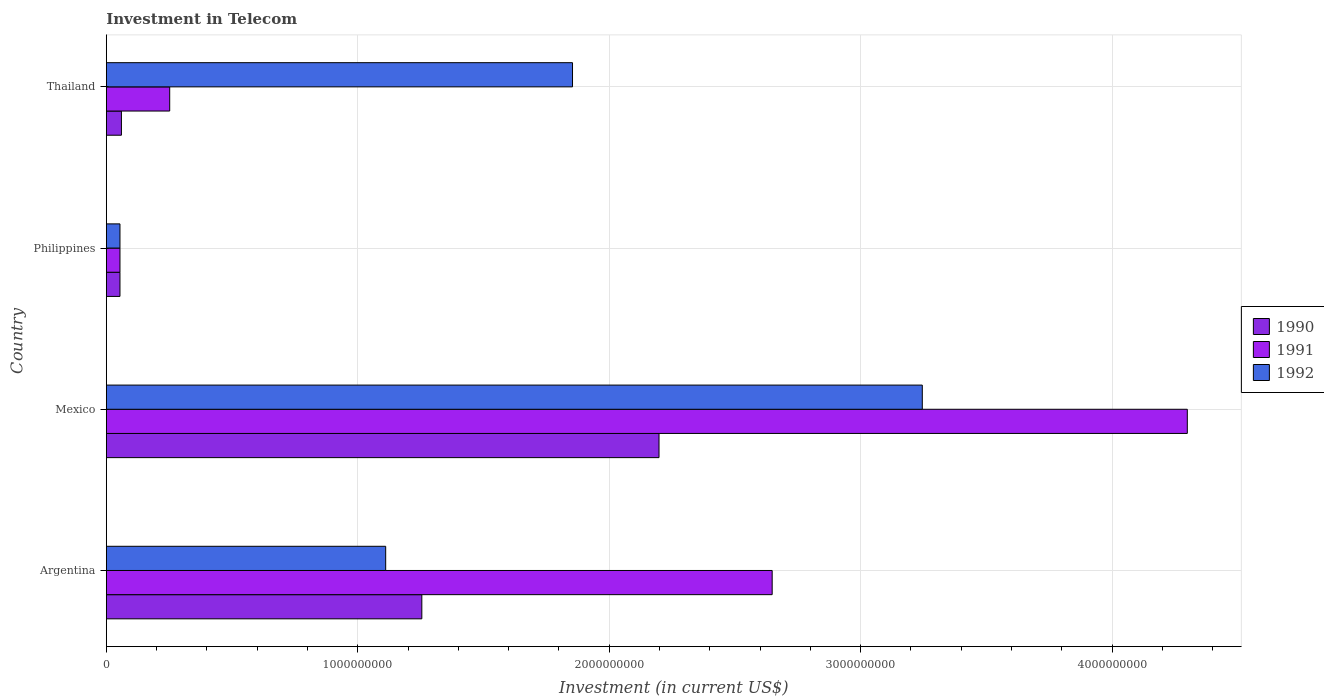How many groups of bars are there?
Offer a very short reply. 4. Are the number of bars per tick equal to the number of legend labels?
Offer a terse response. Yes. Are the number of bars on each tick of the Y-axis equal?
Keep it short and to the point. Yes. How many bars are there on the 2nd tick from the top?
Your answer should be compact. 3. What is the amount invested in telecom in 1992 in Philippines?
Ensure brevity in your answer.  5.42e+07. Across all countries, what is the maximum amount invested in telecom in 1991?
Give a very brief answer. 4.30e+09. Across all countries, what is the minimum amount invested in telecom in 1991?
Your response must be concise. 5.42e+07. What is the total amount invested in telecom in 1990 in the graph?
Offer a terse response. 3.57e+09. What is the difference between the amount invested in telecom in 1990 in Philippines and that in Thailand?
Provide a short and direct response. -5.80e+06. What is the difference between the amount invested in telecom in 1990 in Argentina and the amount invested in telecom in 1991 in Thailand?
Provide a succinct answer. 1.00e+09. What is the average amount invested in telecom in 1992 per country?
Provide a succinct answer. 1.57e+09. What is the difference between the amount invested in telecom in 1990 and amount invested in telecom in 1992 in Mexico?
Provide a succinct answer. -1.05e+09. What is the ratio of the amount invested in telecom in 1990 in Argentina to that in Mexico?
Your answer should be compact. 0.57. What is the difference between the highest and the second highest amount invested in telecom in 1991?
Make the answer very short. 1.65e+09. What is the difference between the highest and the lowest amount invested in telecom in 1992?
Your answer should be very brief. 3.19e+09. In how many countries, is the amount invested in telecom in 1991 greater than the average amount invested in telecom in 1991 taken over all countries?
Your answer should be very brief. 2. What does the 1st bar from the bottom in Thailand represents?
Your answer should be very brief. 1990. Is it the case that in every country, the sum of the amount invested in telecom in 1992 and amount invested in telecom in 1990 is greater than the amount invested in telecom in 1991?
Offer a very short reply. No. How many countries are there in the graph?
Offer a terse response. 4. Are the values on the major ticks of X-axis written in scientific E-notation?
Offer a terse response. No. Does the graph contain any zero values?
Offer a very short reply. No. Where does the legend appear in the graph?
Your answer should be very brief. Center right. How many legend labels are there?
Your response must be concise. 3. What is the title of the graph?
Offer a terse response. Investment in Telecom. Does "1977" appear as one of the legend labels in the graph?
Make the answer very short. No. What is the label or title of the X-axis?
Offer a very short reply. Investment (in current US$). What is the Investment (in current US$) in 1990 in Argentina?
Give a very brief answer. 1.25e+09. What is the Investment (in current US$) in 1991 in Argentina?
Offer a very short reply. 2.65e+09. What is the Investment (in current US$) of 1992 in Argentina?
Your answer should be compact. 1.11e+09. What is the Investment (in current US$) in 1990 in Mexico?
Provide a short and direct response. 2.20e+09. What is the Investment (in current US$) of 1991 in Mexico?
Give a very brief answer. 4.30e+09. What is the Investment (in current US$) of 1992 in Mexico?
Give a very brief answer. 3.24e+09. What is the Investment (in current US$) of 1990 in Philippines?
Your response must be concise. 5.42e+07. What is the Investment (in current US$) in 1991 in Philippines?
Provide a succinct answer. 5.42e+07. What is the Investment (in current US$) in 1992 in Philippines?
Provide a short and direct response. 5.42e+07. What is the Investment (in current US$) in 1990 in Thailand?
Your answer should be compact. 6.00e+07. What is the Investment (in current US$) of 1991 in Thailand?
Your answer should be very brief. 2.52e+08. What is the Investment (in current US$) in 1992 in Thailand?
Make the answer very short. 1.85e+09. Across all countries, what is the maximum Investment (in current US$) of 1990?
Your answer should be very brief. 2.20e+09. Across all countries, what is the maximum Investment (in current US$) of 1991?
Make the answer very short. 4.30e+09. Across all countries, what is the maximum Investment (in current US$) of 1992?
Your answer should be very brief. 3.24e+09. Across all countries, what is the minimum Investment (in current US$) in 1990?
Provide a short and direct response. 5.42e+07. Across all countries, what is the minimum Investment (in current US$) of 1991?
Make the answer very short. 5.42e+07. Across all countries, what is the minimum Investment (in current US$) in 1992?
Your answer should be compact. 5.42e+07. What is the total Investment (in current US$) of 1990 in the graph?
Make the answer very short. 3.57e+09. What is the total Investment (in current US$) of 1991 in the graph?
Make the answer very short. 7.25e+09. What is the total Investment (in current US$) of 1992 in the graph?
Make the answer very short. 6.26e+09. What is the difference between the Investment (in current US$) of 1990 in Argentina and that in Mexico?
Give a very brief answer. -9.43e+08. What is the difference between the Investment (in current US$) of 1991 in Argentina and that in Mexico?
Ensure brevity in your answer.  -1.65e+09. What is the difference between the Investment (in current US$) of 1992 in Argentina and that in Mexico?
Your answer should be very brief. -2.13e+09. What is the difference between the Investment (in current US$) of 1990 in Argentina and that in Philippines?
Your answer should be compact. 1.20e+09. What is the difference between the Investment (in current US$) in 1991 in Argentina and that in Philippines?
Offer a terse response. 2.59e+09. What is the difference between the Investment (in current US$) of 1992 in Argentina and that in Philippines?
Provide a short and direct response. 1.06e+09. What is the difference between the Investment (in current US$) in 1990 in Argentina and that in Thailand?
Your answer should be compact. 1.19e+09. What is the difference between the Investment (in current US$) in 1991 in Argentina and that in Thailand?
Provide a succinct answer. 2.40e+09. What is the difference between the Investment (in current US$) in 1992 in Argentina and that in Thailand?
Offer a very short reply. -7.43e+08. What is the difference between the Investment (in current US$) of 1990 in Mexico and that in Philippines?
Make the answer very short. 2.14e+09. What is the difference between the Investment (in current US$) in 1991 in Mexico and that in Philippines?
Provide a short and direct response. 4.24e+09. What is the difference between the Investment (in current US$) in 1992 in Mexico and that in Philippines?
Keep it short and to the point. 3.19e+09. What is the difference between the Investment (in current US$) in 1990 in Mexico and that in Thailand?
Your response must be concise. 2.14e+09. What is the difference between the Investment (in current US$) in 1991 in Mexico and that in Thailand?
Offer a terse response. 4.05e+09. What is the difference between the Investment (in current US$) of 1992 in Mexico and that in Thailand?
Keep it short and to the point. 1.39e+09. What is the difference between the Investment (in current US$) in 1990 in Philippines and that in Thailand?
Your response must be concise. -5.80e+06. What is the difference between the Investment (in current US$) in 1991 in Philippines and that in Thailand?
Offer a terse response. -1.98e+08. What is the difference between the Investment (in current US$) in 1992 in Philippines and that in Thailand?
Your answer should be very brief. -1.80e+09. What is the difference between the Investment (in current US$) of 1990 in Argentina and the Investment (in current US$) of 1991 in Mexico?
Provide a short and direct response. -3.04e+09. What is the difference between the Investment (in current US$) of 1990 in Argentina and the Investment (in current US$) of 1992 in Mexico?
Your answer should be very brief. -1.99e+09. What is the difference between the Investment (in current US$) of 1991 in Argentina and the Investment (in current US$) of 1992 in Mexico?
Keep it short and to the point. -5.97e+08. What is the difference between the Investment (in current US$) in 1990 in Argentina and the Investment (in current US$) in 1991 in Philippines?
Your answer should be very brief. 1.20e+09. What is the difference between the Investment (in current US$) of 1990 in Argentina and the Investment (in current US$) of 1992 in Philippines?
Give a very brief answer. 1.20e+09. What is the difference between the Investment (in current US$) of 1991 in Argentina and the Investment (in current US$) of 1992 in Philippines?
Ensure brevity in your answer.  2.59e+09. What is the difference between the Investment (in current US$) in 1990 in Argentina and the Investment (in current US$) in 1991 in Thailand?
Make the answer very short. 1.00e+09. What is the difference between the Investment (in current US$) in 1990 in Argentina and the Investment (in current US$) in 1992 in Thailand?
Keep it short and to the point. -5.99e+08. What is the difference between the Investment (in current US$) of 1991 in Argentina and the Investment (in current US$) of 1992 in Thailand?
Your answer should be compact. 7.94e+08. What is the difference between the Investment (in current US$) of 1990 in Mexico and the Investment (in current US$) of 1991 in Philippines?
Ensure brevity in your answer.  2.14e+09. What is the difference between the Investment (in current US$) of 1990 in Mexico and the Investment (in current US$) of 1992 in Philippines?
Your answer should be very brief. 2.14e+09. What is the difference between the Investment (in current US$) of 1991 in Mexico and the Investment (in current US$) of 1992 in Philippines?
Offer a very short reply. 4.24e+09. What is the difference between the Investment (in current US$) in 1990 in Mexico and the Investment (in current US$) in 1991 in Thailand?
Ensure brevity in your answer.  1.95e+09. What is the difference between the Investment (in current US$) of 1990 in Mexico and the Investment (in current US$) of 1992 in Thailand?
Ensure brevity in your answer.  3.44e+08. What is the difference between the Investment (in current US$) in 1991 in Mexico and the Investment (in current US$) in 1992 in Thailand?
Provide a succinct answer. 2.44e+09. What is the difference between the Investment (in current US$) in 1990 in Philippines and the Investment (in current US$) in 1991 in Thailand?
Keep it short and to the point. -1.98e+08. What is the difference between the Investment (in current US$) of 1990 in Philippines and the Investment (in current US$) of 1992 in Thailand?
Your response must be concise. -1.80e+09. What is the difference between the Investment (in current US$) in 1991 in Philippines and the Investment (in current US$) in 1992 in Thailand?
Your answer should be very brief. -1.80e+09. What is the average Investment (in current US$) of 1990 per country?
Provide a succinct answer. 8.92e+08. What is the average Investment (in current US$) in 1991 per country?
Ensure brevity in your answer.  1.81e+09. What is the average Investment (in current US$) in 1992 per country?
Give a very brief answer. 1.57e+09. What is the difference between the Investment (in current US$) of 1990 and Investment (in current US$) of 1991 in Argentina?
Provide a succinct answer. -1.39e+09. What is the difference between the Investment (in current US$) in 1990 and Investment (in current US$) in 1992 in Argentina?
Keep it short and to the point. 1.44e+08. What is the difference between the Investment (in current US$) of 1991 and Investment (in current US$) of 1992 in Argentina?
Your answer should be very brief. 1.54e+09. What is the difference between the Investment (in current US$) in 1990 and Investment (in current US$) in 1991 in Mexico?
Give a very brief answer. -2.10e+09. What is the difference between the Investment (in current US$) of 1990 and Investment (in current US$) of 1992 in Mexico?
Your response must be concise. -1.05e+09. What is the difference between the Investment (in current US$) in 1991 and Investment (in current US$) in 1992 in Mexico?
Keep it short and to the point. 1.05e+09. What is the difference between the Investment (in current US$) in 1990 and Investment (in current US$) in 1991 in Philippines?
Provide a succinct answer. 0. What is the difference between the Investment (in current US$) in 1991 and Investment (in current US$) in 1992 in Philippines?
Offer a very short reply. 0. What is the difference between the Investment (in current US$) of 1990 and Investment (in current US$) of 1991 in Thailand?
Provide a short and direct response. -1.92e+08. What is the difference between the Investment (in current US$) of 1990 and Investment (in current US$) of 1992 in Thailand?
Ensure brevity in your answer.  -1.79e+09. What is the difference between the Investment (in current US$) of 1991 and Investment (in current US$) of 1992 in Thailand?
Provide a succinct answer. -1.60e+09. What is the ratio of the Investment (in current US$) of 1990 in Argentina to that in Mexico?
Offer a terse response. 0.57. What is the ratio of the Investment (in current US$) in 1991 in Argentina to that in Mexico?
Make the answer very short. 0.62. What is the ratio of the Investment (in current US$) in 1992 in Argentina to that in Mexico?
Keep it short and to the point. 0.34. What is the ratio of the Investment (in current US$) of 1990 in Argentina to that in Philippines?
Your answer should be compact. 23.15. What is the ratio of the Investment (in current US$) in 1991 in Argentina to that in Philippines?
Make the answer very short. 48.86. What is the ratio of the Investment (in current US$) in 1992 in Argentina to that in Philippines?
Provide a succinct answer. 20.5. What is the ratio of the Investment (in current US$) of 1990 in Argentina to that in Thailand?
Offer a terse response. 20.91. What is the ratio of the Investment (in current US$) of 1991 in Argentina to that in Thailand?
Make the answer very short. 10.51. What is the ratio of the Investment (in current US$) in 1992 in Argentina to that in Thailand?
Make the answer very short. 0.6. What is the ratio of the Investment (in current US$) in 1990 in Mexico to that in Philippines?
Your answer should be very brief. 40.55. What is the ratio of the Investment (in current US$) of 1991 in Mexico to that in Philippines?
Offer a very short reply. 79.32. What is the ratio of the Investment (in current US$) of 1992 in Mexico to that in Philippines?
Your answer should be very brief. 59.87. What is the ratio of the Investment (in current US$) of 1990 in Mexico to that in Thailand?
Ensure brevity in your answer.  36.63. What is the ratio of the Investment (in current US$) in 1991 in Mexico to that in Thailand?
Provide a short and direct response. 17.06. What is the ratio of the Investment (in current US$) of 1992 in Mexico to that in Thailand?
Your answer should be compact. 1.75. What is the ratio of the Investment (in current US$) of 1990 in Philippines to that in Thailand?
Keep it short and to the point. 0.9. What is the ratio of the Investment (in current US$) in 1991 in Philippines to that in Thailand?
Provide a succinct answer. 0.22. What is the ratio of the Investment (in current US$) in 1992 in Philippines to that in Thailand?
Keep it short and to the point. 0.03. What is the difference between the highest and the second highest Investment (in current US$) in 1990?
Offer a very short reply. 9.43e+08. What is the difference between the highest and the second highest Investment (in current US$) of 1991?
Ensure brevity in your answer.  1.65e+09. What is the difference between the highest and the second highest Investment (in current US$) of 1992?
Provide a short and direct response. 1.39e+09. What is the difference between the highest and the lowest Investment (in current US$) of 1990?
Keep it short and to the point. 2.14e+09. What is the difference between the highest and the lowest Investment (in current US$) in 1991?
Ensure brevity in your answer.  4.24e+09. What is the difference between the highest and the lowest Investment (in current US$) of 1992?
Give a very brief answer. 3.19e+09. 